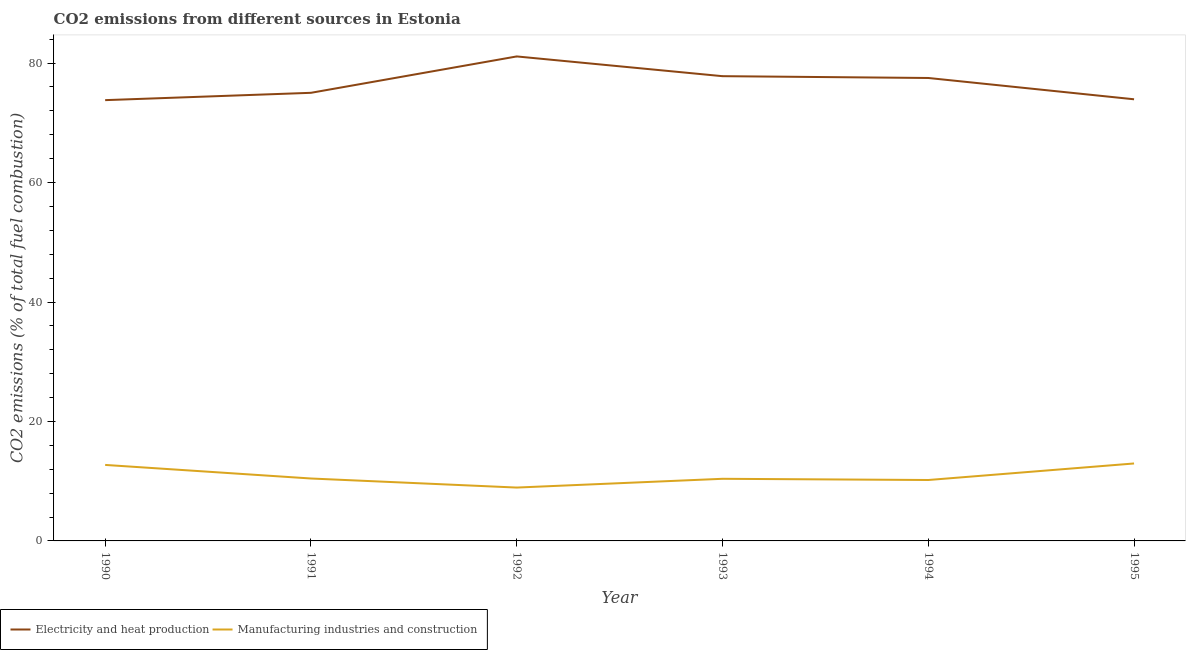Is the number of lines equal to the number of legend labels?
Provide a short and direct response. Yes. What is the co2 emissions due to electricity and heat production in 1995?
Ensure brevity in your answer.  73.94. Across all years, what is the maximum co2 emissions due to electricity and heat production?
Your answer should be compact. 81.11. Across all years, what is the minimum co2 emissions due to manufacturing industries?
Provide a succinct answer. 8.93. In which year was the co2 emissions due to manufacturing industries maximum?
Offer a very short reply. 1995. In which year was the co2 emissions due to electricity and heat production minimum?
Your answer should be very brief. 1990. What is the total co2 emissions due to manufacturing industries in the graph?
Ensure brevity in your answer.  65.67. What is the difference between the co2 emissions due to manufacturing industries in 1990 and that in 1993?
Provide a succinct answer. 2.32. What is the difference between the co2 emissions due to electricity and heat production in 1992 and the co2 emissions due to manufacturing industries in 1994?
Offer a very short reply. 70.92. What is the average co2 emissions due to manufacturing industries per year?
Ensure brevity in your answer.  10.95. In the year 1995, what is the difference between the co2 emissions due to manufacturing industries and co2 emissions due to electricity and heat production?
Provide a succinct answer. -60.97. In how many years, is the co2 emissions due to manufacturing industries greater than 24 %?
Give a very brief answer. 0. What is the ratio of the co2 emissions due to manufacturing industries in 1991 to that in 1992?
Your answer should be very brief. 1.17. Is the co2 emissions due to manufacturing industries in 1990 less than that in 1993?
Provide a short and direct response. No. Is the difference between the co2 emissions due to manufacturing industries in 1992 and 1993 greater than the difference between the co2 emissions due to electricity and heat production in 1992 and 1993?
Your response must be concise. No. What is the difference between the highest and the second highest co2 emissions due to electricity and heat production?
Offer a very short reply. 3.31. What is the difference between the highest and the lowest co2 emissions due to electricity and heat production?
Your answer should be very brief. 7.32. Is the co2 emissions due to manufacturing industries strictly greater than the co2 emissions due to electricity and heat production over the years?
Your response must be concise. No. Is the co2 emissions due to manufacturing industries strictly less than the co2 emissions due to electricity and heat production over the years?
Keep it short and to the point. Yes. Are the values on the major ticks of Y-axis written in scientific E-notation?
Provide a short and direct response. No. Does the graph contain any zero values?
Provide a succinct answer. No. Does the graph contain grids?
Keep it short and to the point. No. Where does the legend appear in the graph?
Your answer should be very brief. Bottom left. How are the legend labels stacked?
Give a very brief answer. Horizontal. What is the title of the graph?
Provide a succinct answer. CO2 emissions from different sources in Estonia. What is the label or title of the Y-axis?
Your response must be concise. CO2 emissions (% of total fuel combustion). What is the CO2 emissions (% of total fuel combustion) in Electricity and heat production in 1990?
Ensure brevity in your answer.  73.8. What is the CO2 emissions (% of total fuel combustion) of Manufacturing industries and construction in 1990?
Offer a terse response. 12.72. What is the CO2 emissions (% of total fuel combustion) in Electricity and heat production in 1991?
Your response must be concise. 75.02. What is the CO2 emissions (% of total fuel combustion) in Manufacturing industries and construction in 1991?
Your response must be concise. 10.45. What is the CO2 emissions (% of total fuel combustion) of Electricity and heat production in 1992?
Offer a very short reply. 81.11. What is the CO2 emissions (% of total fuel combustion) in Manufacturing industries and construction in 1992?
Offer a terse response. 8.93. What is the CO2 emissions (% of total fuel combustion) of Electricity and heat production in 1993?
Offer a very short reply. 77.81. What is the CO2 emissions (% of total fuel combustion) of Manufacturing industries and construction in 1993?
Your answer should be very brief. 10.4. What is the CO2 emissions (% of total fuel combustion) of Electricity and heat production in 1994?
Ensure brevity in your answer.  77.51. What is the CO2 emissions (% of total fuel combustion) in Manufacturing industries and construction in 1994?
Make the answer very short. 10.2. What is the CO2 emissions (% of total fuel combustion) in Electricity and heat production in 1995?
Give a very brief answer. 73.94. What is the CO2 emissions (% of total fuel combustion) in Manufacturing industries and construction in 1995?
Provide a short and direct response. 12.97. Across all years, what is the maximum CO2 emissions (% of total fuel combustion) of Electricity and heat production?
Ensure brevity in your answer.  81.11. Across all years, what is the maximum CO2 emissions (% of total fuel combustion) in Manufacturing industries and construction?
Your response must be concise. 12.97. Across all years, what is the minimum CO2 emissions (% of total fuel combustion) of Electricity and heat production?
Your answer should be compact. 73.8. Across all years, what is the minimum CO2 emissions (% of total fuel combustion) in Manufacturing industries and construction?
Your response must be concise. 8.93. What is the total CO2 emissions (% of total fuel combustion) of Electricity and heat production in the graph?
Your answer should be very brief. 459.19. What is the total CO2 emissions (% of total fuel combustion) in Manufacturing industries and construction in the graph?
Provide a short and direct response. 65.67. What is the difference between the CO2 emissions (% of total fuel combustion) of Electricity and heat production in 1990 and that in 1991?
Keep it short and to the point. -1.23. What is the difference between the CO2 emissions (% of total fuel combustion) in Manufacturing industries and construction in 1990 and that in 1991?
Give a very brief answer. 2.27. What is the difference between the CO2 emissions (% of total fuel combustion) of Electricity and heat production in 1990 and that in 1992?
Your answer should be compact. -7.32. What is the difference between the CO2 emissions (% of total fuel combustion) of Manufacturing industries and construction in 1990 and that in 1992?
Offer a very short reply. 3.79. What is the difference between the CO2 emissions (% of total fuel combustion) of Electricity and heat production in 1990 and that in 1993?
Provide a succinct answer. -4.01. What is the difference between the CO2 emissions (% of total fuel combustion) in Manufacturing industries and construction in 1990 and that in 1993?
Your response must be concise. 2.32. What is the difference between the CO2 emissions (% of total fuel combustion) of Electricity and heat production in 1990 and that in 1994?
Offer a very short reply. -3.71. What is the difference between the CO2 emissions (% of total fuel combustion) in Manufacturing industries and construction in 1990 and that in 1994?
Provide a succinct answer. 2.53. What is the difference between the CO2 emissions (% of total fuel combustion) of Electricity and heat production in 1990 and that in 1995?
Provide a short and direct response. -0.14. What is the difference between the CO2 emissions (% of total fuel combustion) in Manufacturing industries and construction in 1990 and that in 1995?
Your response must be concise. -0.24. What is the difference between the CO2 emissions (% of total fuel combustion) of Electricity and heat production in 1991 and that in 1992?
Your response must be concise. -6.09. What is the difference between the CO2 emissions (% of total fuel combustion) of Manufacturing industries and construction in 1991 and that in 1992?
Your response must be concise. 1.52. What is the difference between the CO2 emissions (% of total fuel combustion) in Electricity and heat production in 1991 and that in 1993?
Your response must be concise. -2.79. What is the difference between the CO2 emissions (% of total fuel combustion) in Manufacturing industries and construction in 1991 and that in 1993?
Your answer should be very brief. 0.05. What is the difference between the CO2 emissions (% of total fuel combustion) of Electricity and heat production in 1991 and that in 1994?
Provide a succinct answer. -2.48. What is the difference between the CO2 emissions (% of total fuel combustion) of Manufacturing industries and construction in 1991 and that in 1994?
Give a very brief answer. 0.25. What is the difference between the CO2 emissions (% of total fuel combustion) of Electricity and heat production in 1991 and that in 1995?
Offer a very short reply. 1.08. What is the difference between the CO2 emissions (% of total fuel combustion) of Manufacturing industries and construction in 1991 and that in 1995?
Make the answer very short. -2.52. What is the difference between the CO2 emissions (% of total fuel combustion) of Electricity and heat production in 1992 and that in 1993?
Make the answer very short. 3.31. What is the difference between the CO2 emissions (% of total fuel combustion) of Manufacturing industries and construction in 1992 and that in 1993?
Your answer should be very brief. -1.47. What is the difference between the CO2 emissions (% of total fuel combustion) of Electricity and heat production in 1992 and that in 1994?
Your answer should be compact. 3.61. What is the difference between the CO2 emissions (% of total fuel combustion) in Manufacturing industries and construction in 1992 and that in 1994?
Your response must be concise. -1.27. What is the difference between the CO2 emissions (% of total fuel combustion) of Electricity and heat production in 1992 and that in 1995?
Your response must be concise. 7.17. What is the difference between the CO2 emissions (% of total fuel combustion) in Manufacturing industries and construction in 1992 and that in 1995?
Provide a short and direct response. -4.04. What is the difference between the CO2 emissions (% of total fuel combustion) in Electricity and heat production in 1993 and that in 1994?
Give a very brief answer. 0.3. What is the difference between the CO2 emissions (% of total fuel combustion) of Manufacturing industries and construction in 1993 and that in 1994?
Offer a terse response. 0.2. What is the difference between the CO2 emissions (% of total fuel combustion) of Electricity and heat production in 1993 and that in 1995?
Provide a short and direct response. 3.87. What is the difference between the CO2 emissions (% of total fuel combustion) of Manufacturing industries and construction in 1993 and that in 1995?
Make the answer very short. -2.57. What is the difference between the CO2 emissions (% of total fuel combustion) in Electricity and heat production in 1994 and that in 1995?
Provide a short and direct response. 3.57. What is the difference between the CO2 emissions (% of total fuel combustion) of Manufacturing industries and construction in 1994 and that in 1995?
Offer a terse response. -2.77. What is the difference between the CO2 emissions (% of total fuel combustion) in Electricity and heat production in 1990 and the CO2 emissions (% of total fuel combustion) in Manufacturing industries and construction in 1991?
Keep it short and to the point. 63.35. What is the difference between the CO2 emissions (% of total fuel combustion) in Electricity and heat production in 1990 and the CO2 emissions (% of total fuel combustion) in Manufacturing industries and construction in 1992?
Your answer should be very brief. 64.87. What is the difference between the CO2 emissions (% of total fuel combustion) in Electricity and heat production in 1990 and the CO2 emissions (% of total fuel combustion) in Manufacturing industries and construction in 1993?
Give a very brief answer. 63.4. What is the difference between the CO2 emissions (% of total fuel combustion) of Electricity and heat production in 1990 and the CO2 emissions (% of total fuel combustion) of Manufacturing industries and construction in 1994?
Offer a terse response. 63.6. What is the difference between the CO2 emissions (% of total fuel combustion) in Electricity and heat production in 1990 and the CO2 emissions (% of total fuel combustion) in Manufacturing industries and construction in 1995?
Make the answer very short. 60.83. What is the difference between the CO2 emissions (% of total fuel combustion) of Electricity and heat production in 1991 and the CO2 emissions (% of total fuel combustion) of Manufacturing industries and construction in 1992?
Ensure brevity in your answer.  66.09. What is the difference between the CO2 emissions (% of total fuel combustion) of Electricity and heat production in 1991 and the CO2 emissions (% of total fuel combustion) of Manufacturing industries and construction in 1993?
Provide a succinct answer. 64.62. What is the difference between the CO2 emissions (% of total fuel combustion) of Electricity and heat production in 1991 and the CO2 emissions (% of total fuel combustion) of Manufacturing industries and construction in 1994?
Give a very brief answer. 64.83. What is the difference between the CO2 emissions (% of total fuel combustion) of Electricity and heat production in 1991 and the CO2 emissions (% of total fuel combustion) of Manufacturing industries and construction in 1995?
Provide a succinct answer. 62.06. What is the difference between the CO2 emissions (% of total fuel combustion) of Electricity and heat production in 1992 and the CO2 emissions (% of total fuel combustion) of Manufacturing industries and construction in 1993?
Your answer should be very brief. 70.71. What is the difference between the CO2 emissions (% of total fuel combustion) in Electricity and heat production in 1992 and the CO2 emissions (% of total fuel combustion) in Manufacturing industries and construction in 1994?
Your answer should be compact. 70.92. What is the difference between the CO2 emissions (% of total fuel combustion) in Electricity and heat production in 1992 and the CO2 emissions (% of total fuel combustion) in Manufacturing industries and construction in 1995?
Your answer should be very brief. 68.15. What is the difference between the CO2 emissions (% of total fuel combustion) in Electricity and heat production in 1993 and the CO2 emissions (% of total fuel combustion) in Manufacturing industries and construction in 1994?
Make the answer very short. 67.61. What is the difference between the CO2 emissions (% of total fuel combustion) in Electricity and heat production in 1993 and the CO2 emissions (% of total fuel combustion) in Manufacturing industries and construction in 1995?
Ensure brevity in your answer.  64.84. What is the difference between the CO2 emissions (% of total fuel combustion) in Electricity and heat production in 1994 and the CO2 emissions (% of total fuel combustion) in Manufacturing industries and construction in 1995?
Your answer should be compact. 64.54. What is the average CO2 emissions (% of total fuel combustion) in Electricity and heat production per year?
Provide a short and direct response. 76.53. What is the average CO2 emissions (% of total fuel combustion) of Manufacturing industries and construction per year?
Provide a succinct answer. 10.95. In the year 1990, what is the difference between the CO2 emissions (% of total fuel combustion) of Electricity and heat production and CO2 emissions (% of total fuel combustion) of Manufacturing industries and construction?
Give a very brief answer. 61.07. In the year 1991, what is the difference between the CO2 emissions (% of total fuel combustion) in Electricity and heat production and CO2 emissions (% of total fuel combustion) in Manufacturing industries and construction?
Provide a short and direct response. 64.57. In the year 1992, what is the difference between the CO2 emissions (% of total fuel combustion) of Electricity and heat production and CO2 emissions (% of total fuel combustion) of Manufacturing industries and construction?
Your answer should be compact. 72.18. In the year 1993, what is the difference between the CO2 emissions (% of total fuel combustion) in Electricity and heat production and CO2 emissions (% of total fuel combustion) in Manufacturing industries and construction?
Provide a short and direct response. 67.41. In the year 1994, what is the difference between the CO2 emissions (% of total fuel combustion) of Electricity and heat production and CO2 emissions (% of total fuel combustion) of Manufacturing industries and construction?
Your answer should be very brief. 67.31. In the year 1995, what is the difference between the CO2 emissions (% of total fuel combustion) of Electricity and heat production and CO2 emissions (% of total fuel combustion) of Manufacturing industries and construction?
Provide a short and direct response. 60.97. What is the ratio of the CO2 emissions (% of total fuel combustion) of Electricity and heat production in 1990 to that in 1991?
Ensure brevity in your answer.  0.98. What is the ratio of the CO2 emissions (% of total fuel combustion) in Manufacturing industries and construction in 1990 to that in 1991?
Ensure brevity in your answer.  1.22. What is the ratio of the CO2 emissions (% of total fuel combustion) of Electricity and heat production in 1990 to that in 1992?
Give a very brief answer. 0.91. What is the ratio of the CO2 emissions (% of total fuel combustion) in Manufacturing industries and construction in 1990 to that in 1992?
Your answer should be very brief. 1.42. What is the ratio of the CO2 emissions (% of total fuel combustion) of Electricity and heat production in 1990 to that in 1993?
Keep it short and to the point. 0.95. What is the ratio of the CO2 emissions (% of total fuel combustion) of Manufacturing industries and construction in 1990 to that in 1993?
Provide a succinct answer. 1.22. What is the ratio of the CO2 emissions (% of total fuel combustion) in Electricity and heat production in 1990 to that in 1994?
Your answer should be compact. 0.95. What is the ratio of the CO2 emissions (% of total fuel combustion) in Manufacturing industries and construction in 1990 to that in 1994?
Provide a succinct answer. 1.25. What is the ratio of the CO2 emissions (% of total fuel combustion) in Manufacturing industries and construction in 1990 to that in 1995?
Keep it short and to the point. 0.98. What is the ratio of the CO2 emissions (% of total fuel combustion) of Electricity and heat production in 1991 to that in 1992?
Give a very brief answer. 0.92. What is the ratio of the CO2 emissions (% of total fuel combustion) in Manufacturing industries and construction in 1991 to that in 1992?
Provide a short and direct response. 1.17. What is the ratio of the CO2 emissions (% of total fuel combustion) of Electricity and heat production in 1991 to that in 1993?
Provide a succinct answer. 0.96. What is the ratio of the CO2 emissions (% of total fuel combustion) of Manufacturing industries and construction in 1991 to that in 1993?
Your answer should be very brief. 1. What is the ratio of the CO2 emissions (% of total fuel combustion) of Manufacturing industries and construction in 1991 to that in 1994?
Your answer should be compact. 1.02. What is the ratio of the CO2 emissions (% of total fuel combustion) of Electricity and heat production in 1991 to that in 1995?
Offer a very short reply. 1.01. What is the ratio of the CO2 emissions (% of total fuel combustion) of Manufacturing industries and construction in 1991 to that in 1995?
Offer a terse response. 0.81. What is the ratio of the CO2 emissions (% of total fuel combustion) in Electricity and heat production in 1992 to that in 1993?
Make the answer very short. 1.04. What is the ratio of the CO2 emissions (% of total fuel combustion) in Manufacturing industries and construction in 1992 to that in 1993?
Offer a terse response. 0.86. What is the ratio of the CO2 emissions (% of total fuel combustion) in Electricity and heat production in 1992 to that in 1994?
Your answer should be compact. 1.05. What is the ratio of the CO2 emissions (% of total fuel combustion) in Manufacturing industries and construction in 1992 to that in 1994?
Offer a very short reply. 0.88. What is the ratio of the CO2 emissions (% of total fuel combustion) in Electricity and heat production in 1992 to that in 1995?
Keep it short and to the point. 1.1. What is the ratio of the CO2 emissions (% of total fuel combustion) of Manufacturing industries and construction in 1992 to that in 1995?
Keep it short and to the point. 0.69. What is the ratio of the CO2 emissions (% of total fuel combustion) in Electricity and heat production in 1993 to that in 1994?
Your answer should be compact. 1. What is the ratio of the CO2 emissions (% of total fuel combustion) of Manufacturing industries and construction in 1993 to that in 1994?
Give a very brief answer. 1.02. What is the ratio of the CO2 emissions (% of total fuel combustion) of Electricity and heat production in 1993 to that in 1995?
Make the answer very short. 1.05. What is the ratio of the CO2 emissions (% of total fuel combustion) in Manufacturing industries and construction in 1993 to that in 1995?
Provide a short and direct response. 0.8. What is the ratio of the CO2 emissions (% of total fuel combustion) of Electricity and heat production in 1994 to that in 1995?
Keep it short and to the point. 1.05. What is the ratio of the CO2 emissions (% of total fuel combustion) of Manufacturing industries and construction in 1994 to that in 1995?
Offer a very short reply. 0.79. What is the difference between the highest and the second highest CO2 emissions (% of total fuel combustion) of Electricity and heat production?
Offer a terse response. 3.31. What is the difference between the highest and the second highest CO2 emissions (% of total fuel combustion) in Manufacturing industries and construction?
Give a very brief answer. 0.24. What is the difference between the highest and the lowest CO2 emissions (% of total fuel combustion) of Electricity and heat production?
Your answer should be very brief. 7.32. What is the difference between the highest and the lowest CO2 emissions (% of total fuel combustion) in Manufacturing industries and construction?
Offer a terse response. 4.04. 